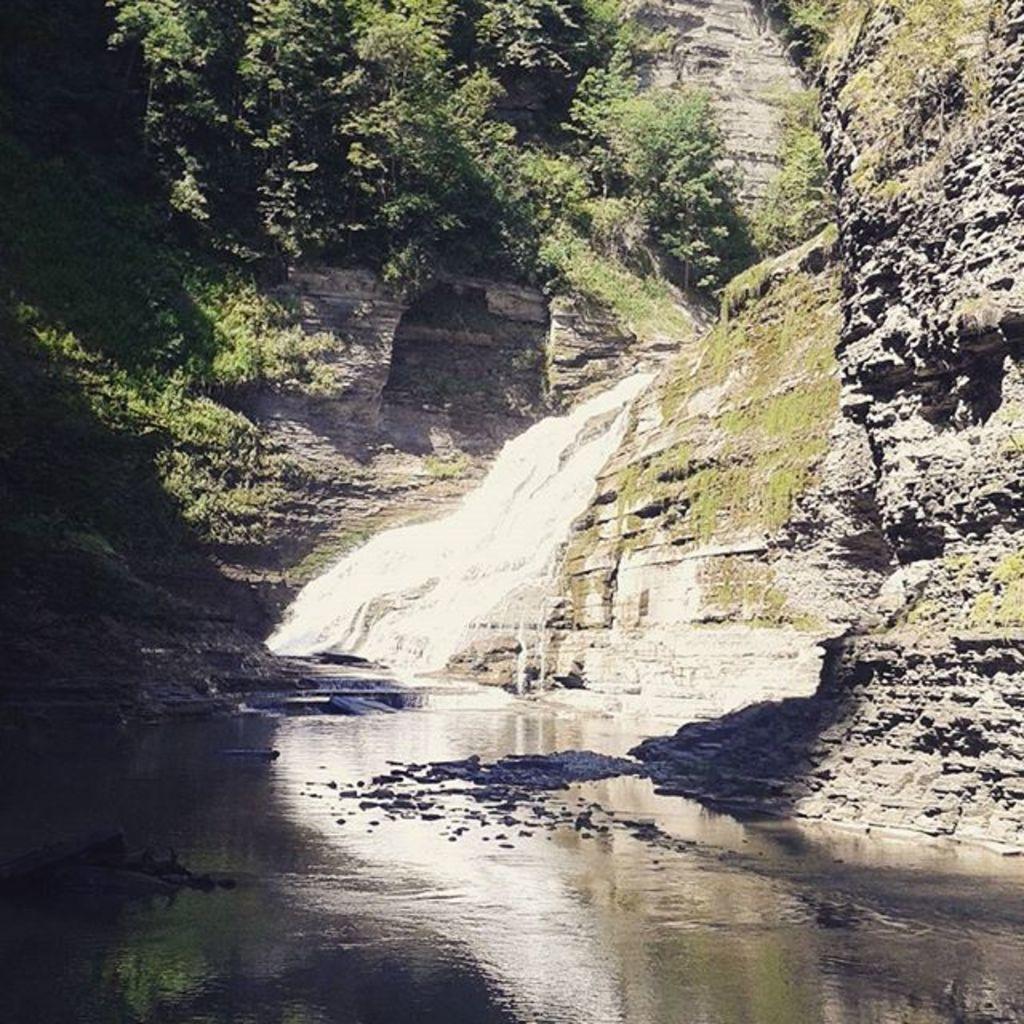Can you describe this image briefly? In this image I can see a waterfall, trees and mountains. This image is taken may be during a day. 